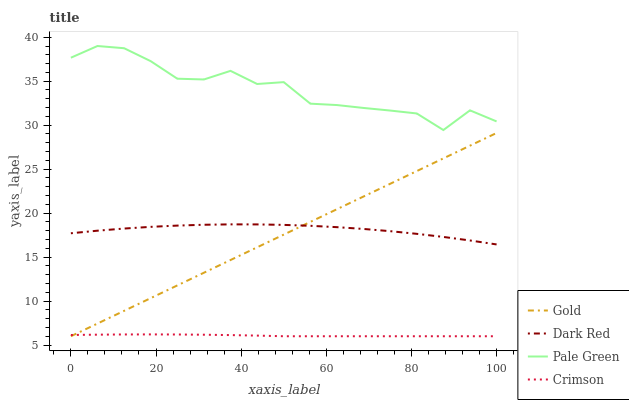Does Crimson have the minimum area under the curve?
Answer yes or no. Yes. Does Pale Green have the maximum area under the curve?
Answer yes or no. Yes. Does Dark Red have the minimum area under the curve?
Answer yes or no. No. Does Dark Red have the maximum area under the curve?
Answer yes or no. No. Is Gold the smoothest?
Answer yes or no. Yes. Is Pale Green the roughest?
Answer yes or no. Yes. Is Dark Red the smoothest?
Answer yes or no. No. Is Dark Red the roughest?
Answer yes or no. No. Does Crimson have the lowest value?
Answer yes or no. Yes. Does Dark Red have the lowest value?
Answer yes or no. No. Does Pale Green have the highest value?
Answer yes or no. Yes. Does Dark Red have the highest value?
Answer yes or no. No. Is Dark Red less than Pale Green?
Answer yes or no. Yes. Is Dark Red greater than Crimson?
Answer yes or no. Yes. Does Dark Red intersect Gold?
Answer yes or no. Yes. Is Dark Red less than Gold?
Answer yes or no. No. Is Dark Red greater than Gold?
Answer yes or no. No. Does Dark Red intersect Pale Green?
Answer yes or no. No. 